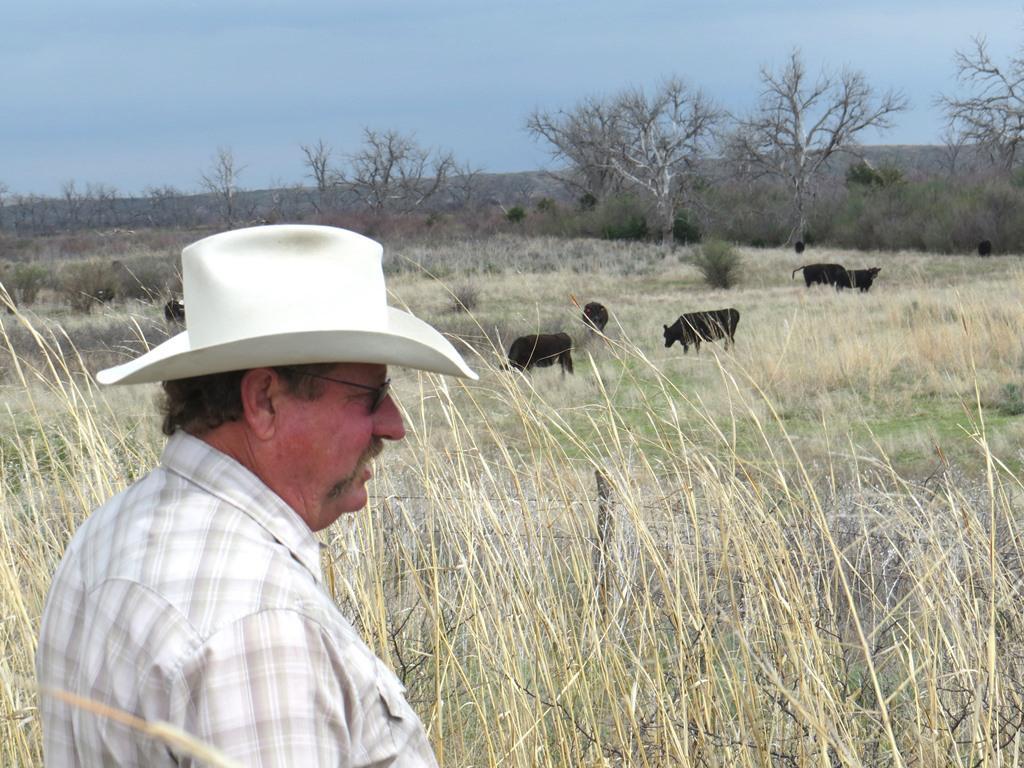Could you give a brief overview of what you see in this image? In this picture I can see few cows and I can see grass on the ground and a man standing, he is wearing a cap and sunglasses and I can see trees and a blue sky. 